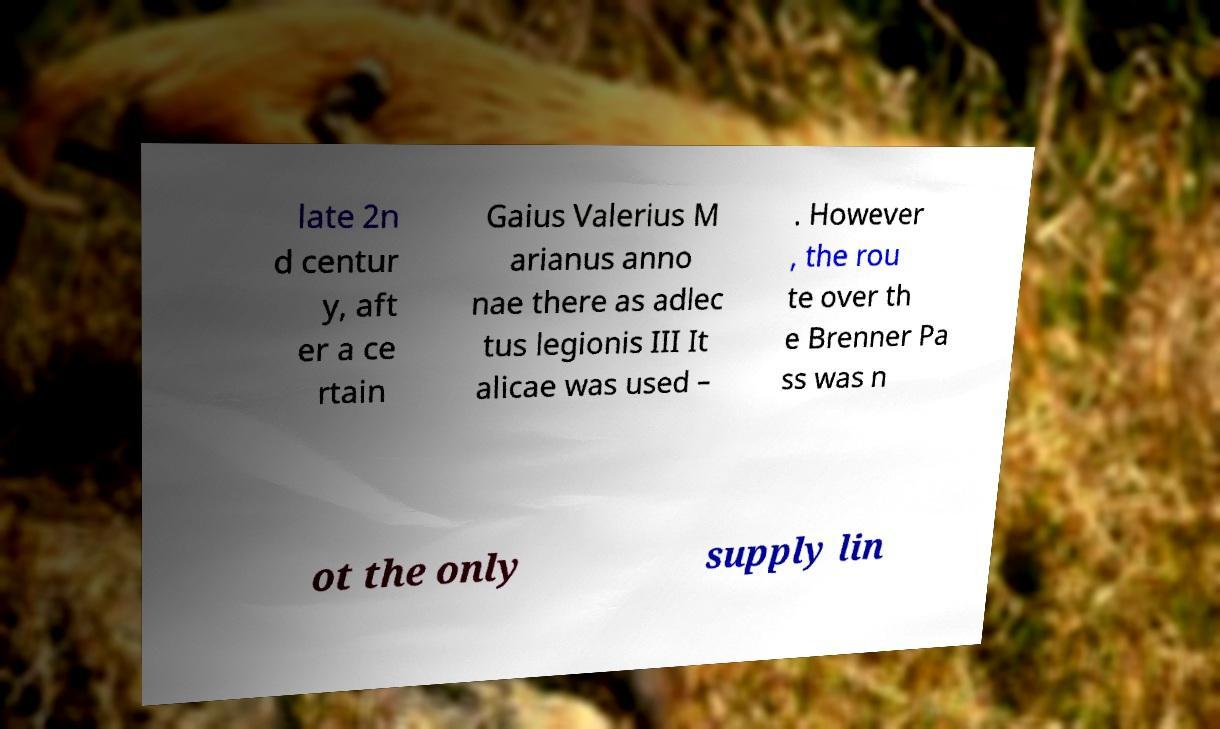I need the written content from this picture converted into text. Can you do that? late 2n d centur y, aft er a ce rtain Gaius Valerius M arianus anno nae there as adlec tus legionis III It alicae was used – . However , the rou te over th e Brenner Pa ss was n ot the only supply lin 